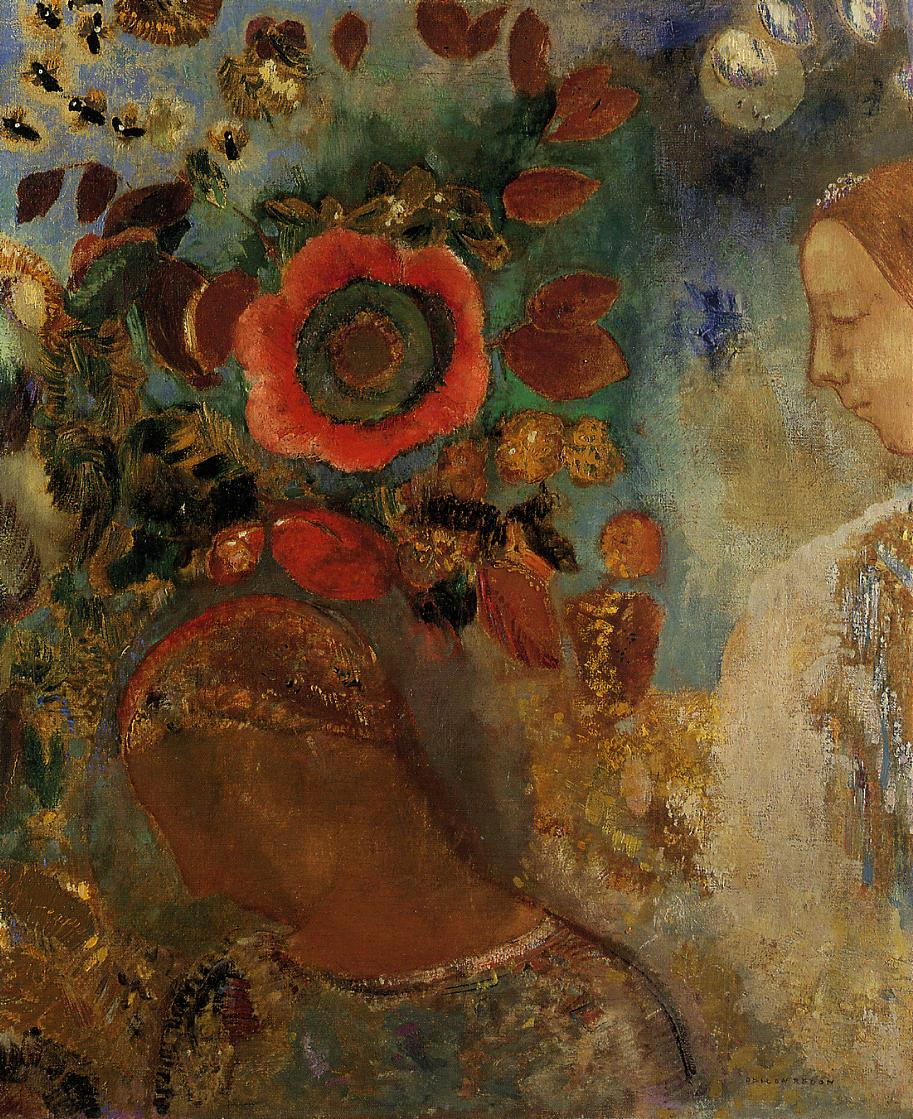What might have inspired the artist to create such a composition? The artist might have been inspired by the profound connection between humans and nature, aiming to explore themes of harmony and introspection. The vivid and encompassing floral setting could represent nature's all-encompassing beauty, while the serene expression of the woman suggests a deep state of contemplation, reflecting a moment of inner peace and unity with the natural world. The impressionistic style, with its fluid brushstrokes and vibrant colors, indicates a desire to capture the fleeting beauty and the emotional resonance of the scene. Could the painting have any symbolic meanings? Yes, the painting could be rich in symbolic meanings. The large red flower might symbolize passion or vitality, drawing a direct connection to the human spirit. The woman's peaceful demeanor could represent tranquility and introspection, suggesting a moment of inward reflection amidst the bustling vibrancy of life. The seamless blending of her figure with the natural surroundings could symbolize the unity between humanity and nature, highlighting an intrinsic bond that evokes existential contemplation. Additionally, the impressionistic technique may symbolize the transient nature of beauty and moments in life, capturing fleeting emotions and memories. 